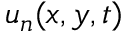Convert formula to latex. <formula><loc_0><loc_0><loc_500><loc_500>u _ { n } ( x , y , t )</formula> 